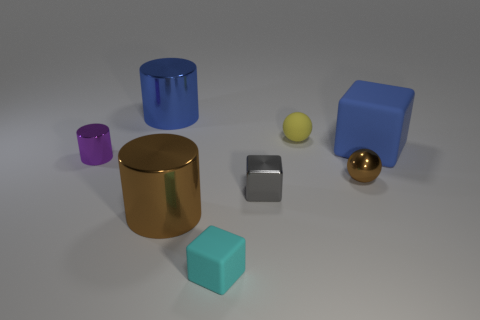What number of other objects are the same size as the purple thing?
Your response must be concise. 4. What is the material of the thing on the left side of the large metallic object that is behind the ball that is to the right of the matte sphere?
Ensure brevity in your answer.  Metal. There is a shiny block; does it have the same size as the metal object in front of the tiny gray shiny cube?
Provide a succinct answer. No. What is the size of the matte object that is on the left side of the blue block and in front of the yellow sphere?
Your answer should be very brief. Small. Is there a big metallic sphere that has the same color as the small metal cylinder?
Provide a short and direct response. No. There is a cube behind the small brown metal thing that is to the right of the tiny yellow thing; what is its color?
Your answer should be compact. Blue. Are there fewer blue objects left of the large cube than blue metallic cylinders right of the brown metal sphere?
Your response must be concise. No. Does the blue cylinder have the same size as the brown ball?
Your answer should be very brief. No. There is a metal thing that is in front of the tiny purple metallic cylinder and to the left of the small gray metal cube; what is its shape?
Provide a short and direct response. Cylinder. What number of other spheres are made of the same material as the yellow ball?
Provide a succinct answer. 0. 